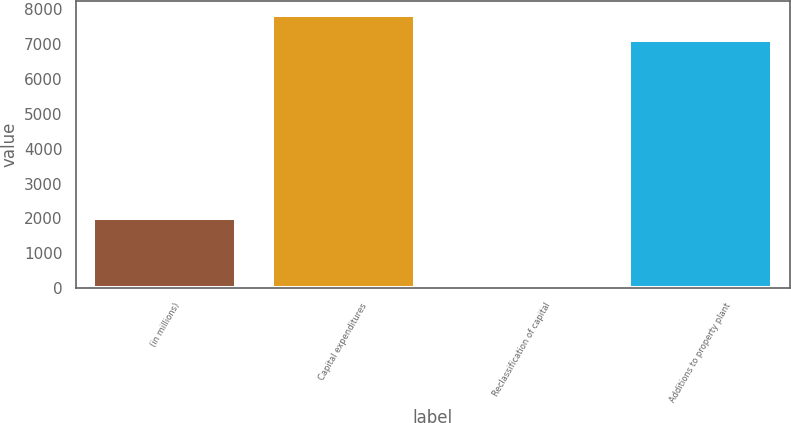<chart> <loc_0><loc_0><loc_500><loc_500><bar_chart><fcel>(in millions)<fcel>Capital expenditures<fcel>Reclassification of capital<fcel>Additions to property plant<nl><fcel>2008<fcel>7827.6<fcel>30<fcel>7116<nl></chart> 